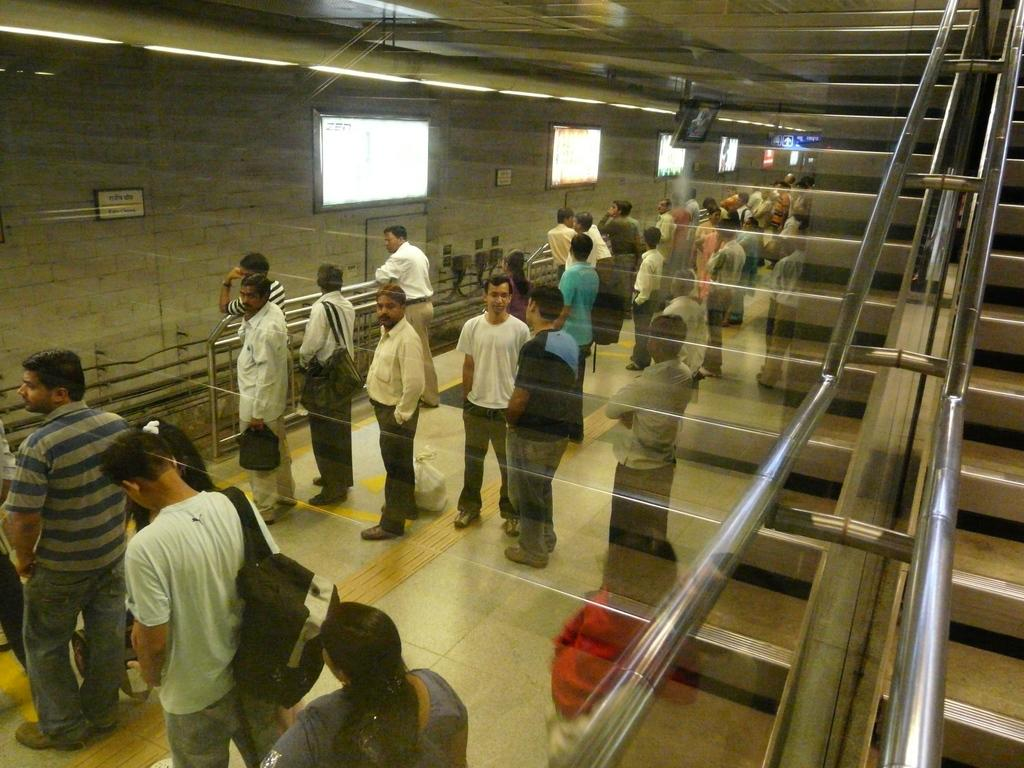What can be seen on the right side of the image? There are stairs on the right side of the image. What is located on the left side of the image? There is a glass on the left side of the image. What can be observed through the glass? People are visible through the glass. What type of food is being served on the wall in the image? There is no food or wall present in the image; it features stairs and a glass with people visible through it. Can you describe the ear that is visible in the image? There is no ear present in the image. 